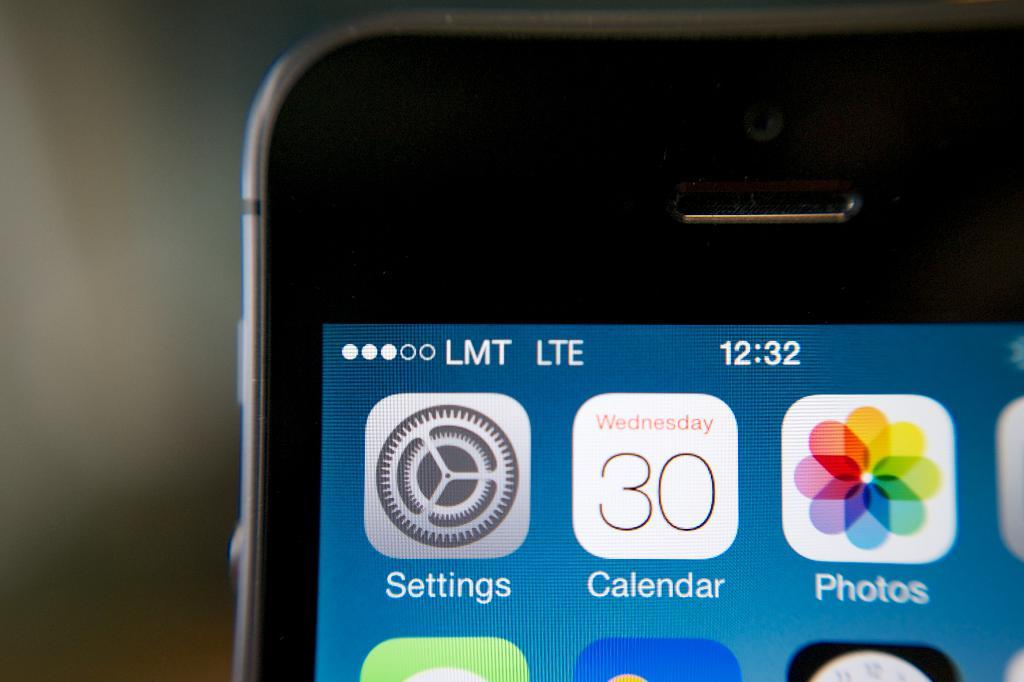Provide a one-sentence caption for the provided image. A phone with the calendar app with the calendar app showing the day Wednesday. 